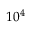<formula> <loc_0><loc_0><loc_500><loc_500>1 0 ^ { 4 }</formula> 